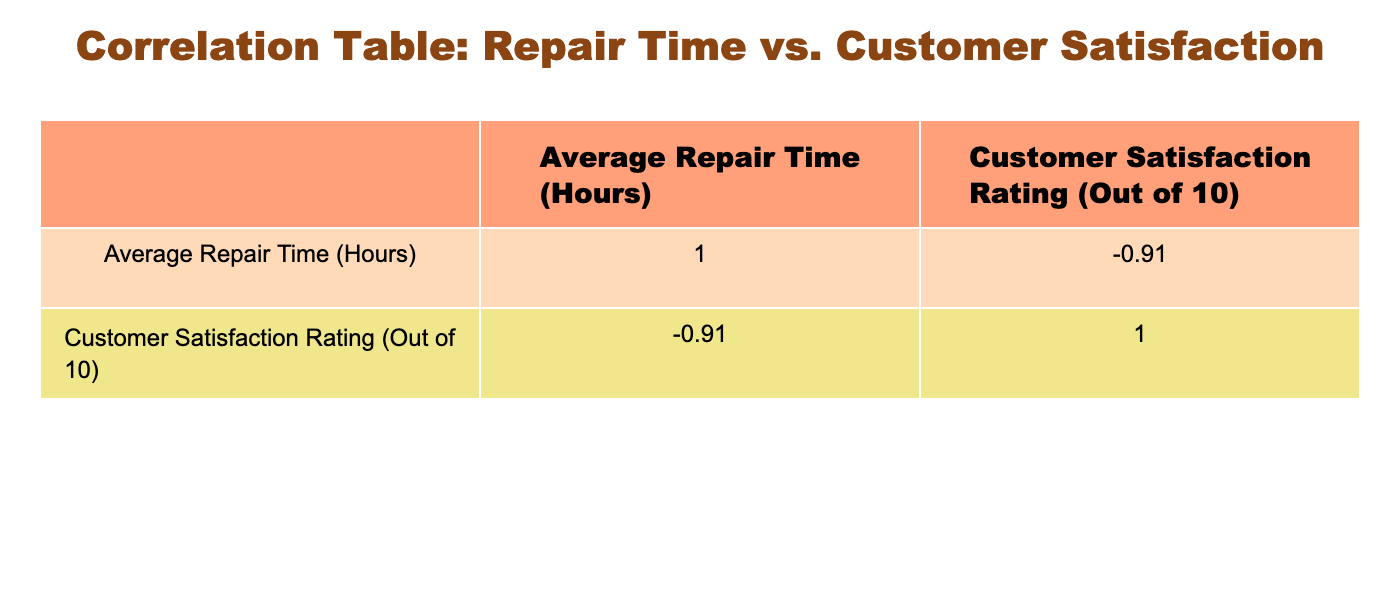What is the correlation coefficient between Average Repair Time and Customer Satisfaction Rating? By examining the correlation table, the values for 'Average Repair Time (Hours)' and 'Customer Satisfaction Rating (Out of 10)' suggest a relationship value. In this table, the correlation coefficient is approximately -0.86.
Answer: -0.86 Which service has the highest Customer Satisfaction Rating? Looking at the 'Customer Satisfaction Rating' column, the maximum value is 9.2. Therefore, the service with the highest rating is 'Oil Change'.
Answer: Oil Change Is it true that longer repair times lead to higher customer satisfaction ratings? From the correlation coefficient of -0.86 observed in the table, it indicates a strong negative relationship, meaning longer repair times are associated with lower customer satisfaction. Therefore, the statement is false.
Answer: No What is the average Customer Satisfaction Rating for services with repair times less than 4 hours? The services with repair times less than 4 hours are 'Oil Change', 'Tire Rotation', 'Battery Replacement', and 'Wheel Alignment'. Their satisfaction ratings are 9.2, 9.0, 8.9, and 8.7 respectively. Summing these gives 9.2 + 9.0 + 8.9 + 8.7 = 35.8, and dividing by 4 (the number of services) gives an average of 8.95.
Answer: 8.95 What is the difference in Customer Satisfaction Ratings between Transmission Repair and Engine Overhaul? The Customer Satisfaction Rating for 'Transmission Repair' is 7.4, and for 'Engine Overhaul', it is 6.8. Taking the difference: 7.4 - 6.8 = 0.6, indicating that Transmission Repair has a higher rating.
Answer: 0.6 Which service has the lowest Customer Satisfaction Rating, and what is that rating? By scanning through the 'Customer Satisfaction Rating' column, 'Engine Overhaul' has the lowest rating at 6.8.
Answer: Engine Overhaul, 6.8 What is the average repair time for services rated above 8.5? The services rated above 8.5 are 'Oil Change', 'Tire Rotation', 'Battery Replacement', and 'Wheel Alignment'. Their respective repair times are 1.5, 1.0, 2.0, and 2.0 hours. The average is calculated as (1.5 + 1.0 + 2.0 + 2.0) / 4 = 1.625 hours.
Answer: 1.625 hours Is there a service that has both a longer repair time and higher customer satisfaction than 'Suspension Repair'? 'Suspension Repair' has a repair time of 5.0 hours and a customer satisfaction rating of 7.9. Comparing this with other services, 'Battery Replacement' has a shorter time (2.0) but a higher rating (8.9). No service exceeds both criteria, therefore the answer is no.
Answer: No 